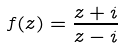Convert formula to latex. <formula><loc_0><loc_0><loc_500><loc_500>f ( z ) = \frac { z + i } { z - i }</formula> 